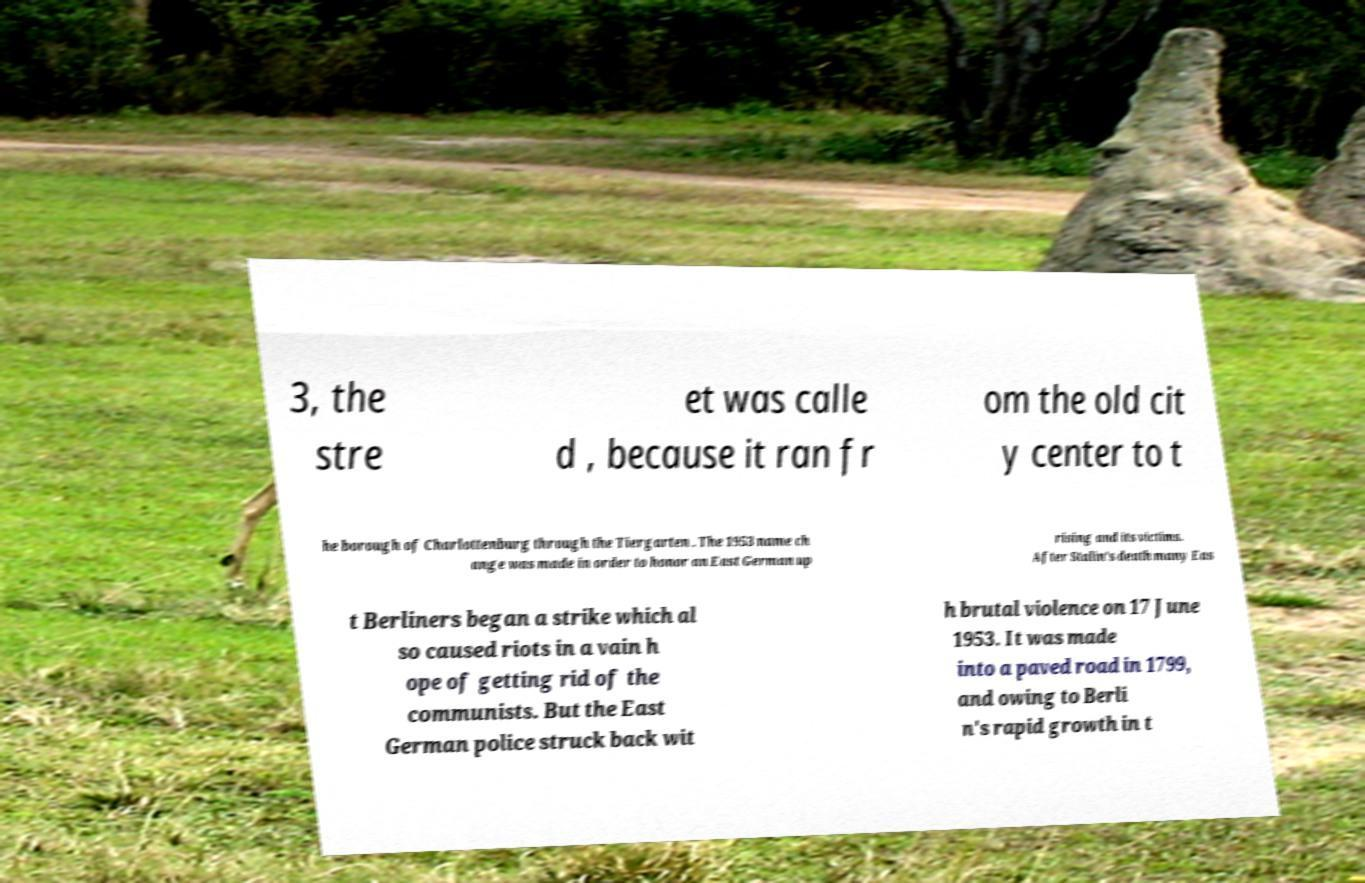Please read and relay the text visible in this image. What does it say? 3, the stre et was calle d , because it ran fr om the old cit y center to t he borough of Charlottenburg through the Tiergarten . The 1953 name ch ange was made in order to honor an East German up rising and its victims. After Stalin's death many Eas t Berliners began a strike which al so caused riots in a vain h ope of getting rid of the communists. But the East German police struck back wit h brutal violence on 17 June 1953. It was made into a paved road in 1799, and owing to Berli n's rapid growth in t 